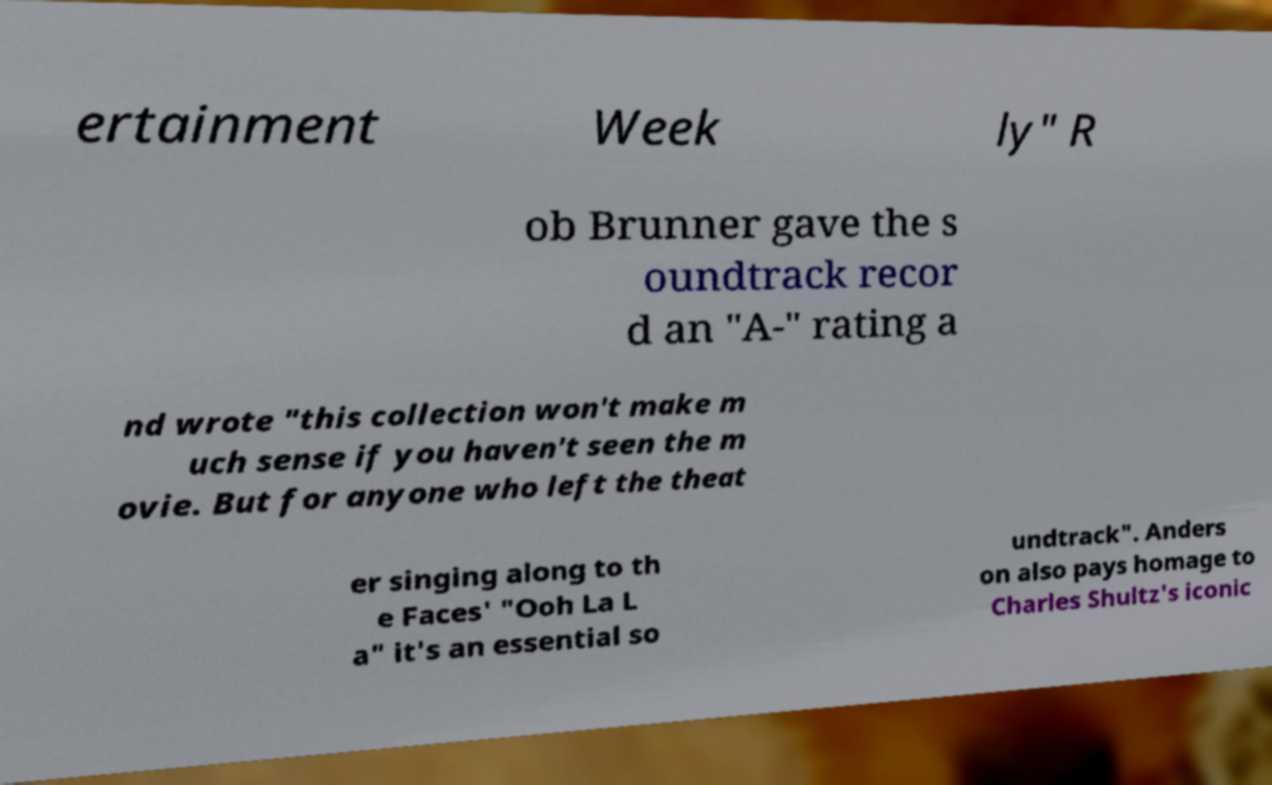I need the written content from this picture converted into text. Can you do that? ertainment Week ly" R ob Brunner gave the s oundtrack recor d an "A-" rating a nd wrote "this collection won't make m uch sense if you haven't seen the m ovie. But for anyone who left the theat er singing along to th e Faces' "Ooh La L a" it's an essential so undtrack". Anders on also pays homage to Charles Shultz's iconic 